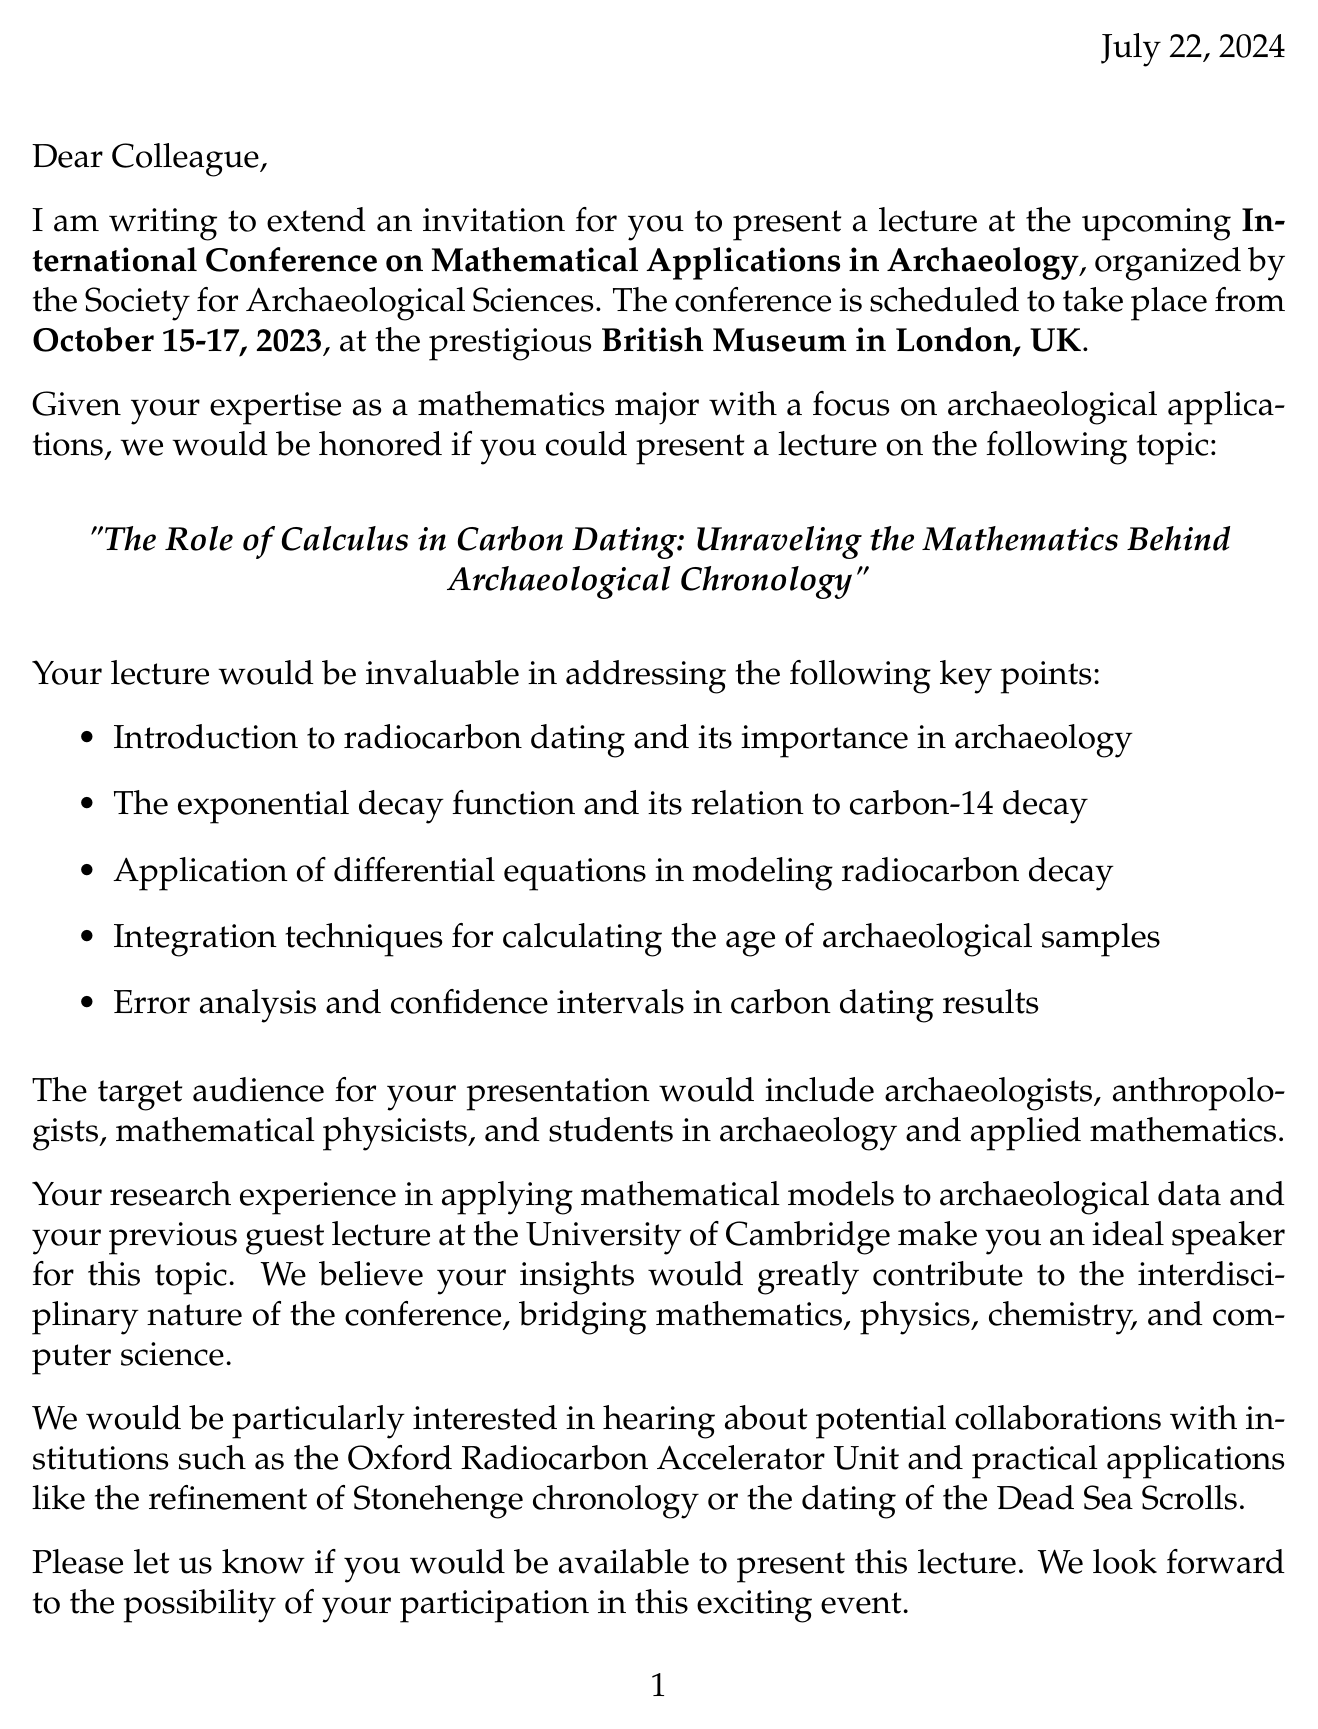What are the dates of the conference? The dates of the conference are mentioned in the event details of the document.
Answer: October 15-17, 2023 Who is organizing the conference? The organizer of the conference is specified in the document.
Answer: Society for Archaeological Sciences What is the lecture topic? The lecture topic is clearly stated in a specific section of the letter.
Answer: The Role of Calculus in Carbon Dating: Unraveling the Mathematics Behind Archaeological Chronology What key point discusses the mathematical model? This key point refers to the use of mathematical models in the context of carbon dating discussed in the document.
Answer: Application of differential equations in modeling radiocarbon decay Who were the authors of the relevant research paper? The authors are listed in the section about relevant research, providing specific names.
Answer: Dr. Emily Bronson and Dr. Michael Chen Which institution is mentioned for potential collaboration? The document lists potential collaborations, providing specific institutions.
Answer: Oxford Radiocarbon Accelerator Unit What type of audience is targeted for the lecture? The target audience is mentioned in the document, detailing specific groups of people who would be interested.
Answer: Archaeologists, Anthropologists, Mathematical physicists, Undergraduate and graduate students in archaeology and applied mathematics What practical application is included related to the Dead Sea Scrolls? The practical applications section includes specific examples related to archaeological contexts.
Answer: Dating of Dead Sea Scrolls What is the venue for the conference? The venue is mentioned clearly in the document under event details.
Answer: British Museum, London, UK 